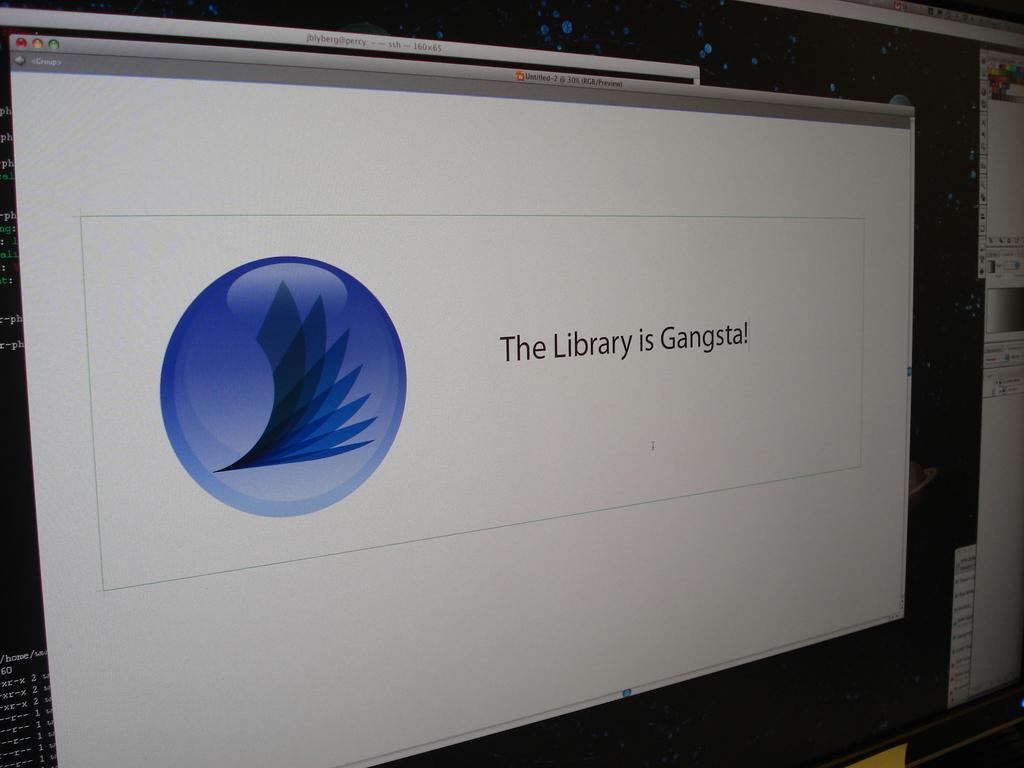What is the library?
Provide a succinct answer. Gangsta. 